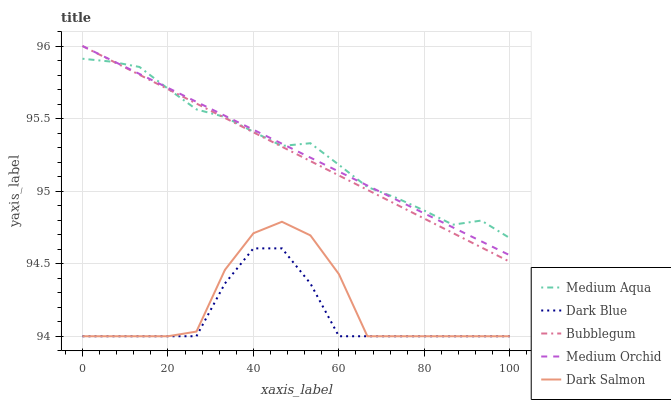Does Dark Blue have the minimum area under the curve?
Answer yes or no. Yes. Does Medium Aqua have the maximum area under the curve?
Answer yes or no. Yes. Does Medium Orchid have the minimum area under the curve?
Answer yes or no. No. Does Medium Orchid have the maximum area under the curve?
Answer yes or no. No. Is Medium Orchid the smoothest?
Answer yes or no. Yes. Is Dark Salmon the roughest?
Answer yes or no. Yes. Is Medium Aqua the smoothest?
Answer yes or no. No. Is Medium Aqua the roughest?
Answer yes or no. No. Does Medium Orchid have the lowest value?
Answer yes or no. No. Does Bubblegum have the highest value?
Answer yes or no. Yes. Does Medium Aqua have the highest value?
Answer yes or no. No. Is Dark Salmon less than Medium Orchid?
Answer yes or no. Yes. Is Bubblegum greater than Dark Salmon?
Answer yes or no. Yes. Does Bubblegum intersect Medium Orchid?
Answer yes or no. Yes. Is Bubblegum less than Medium Orchid?
Answer yes or no. No. Is Bubblegum greater than Medium Orchid?
Answer yes or no. No. Does Dark Salmon intersect Medium Orchid?
Answer yes or no. No. 